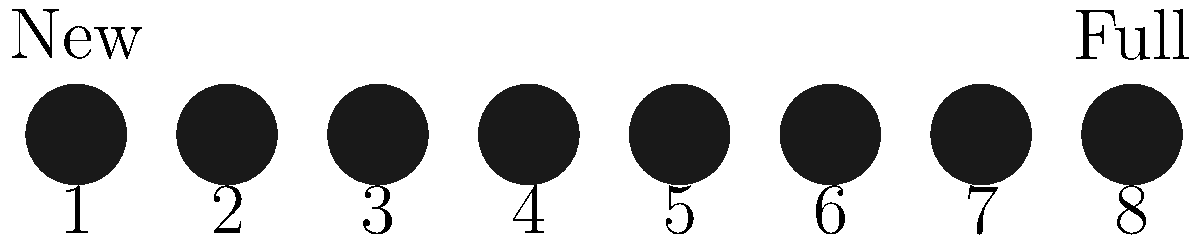As a car enthusiast who's familiar with precision in repairs, you might appreciate the importance of timing in astronomy. Looking at the lunar phase diagram above, which number represents the First Quarter Moon? To answer this question, let's break down the lunar phases step-by-step:

1. The diagram shows 8 phases of the moon, numbered from 1 to 8.
2. The leftmost moon (1) is completely dark, representing the New Moon.
3. The rightmost moon (8) is completely illuminated, representing the Full Moon.
4. The First Quarter Moon occurs when the right half of the moon is illuminated from our perspective on Earth.
5. This happens approximately halfway between the New Moon and Full Moon.
6. In the diagram, we can see that the moon labeled '3' shows exactly half of its face illuminated on the right side.

Just as precision is crucial in using a BMW Alpine White Scratch & Chip Repair Kit, accuracy in identifying lunar phases is important in astronomy. The First Quarter Moon, represented by number 3 in the diagram, is a precise moment when exactly half of the moon's visible surface is illuminated, much like ensuring half of a repaired area is perfectly matched in color and texture.
Answer: 3 